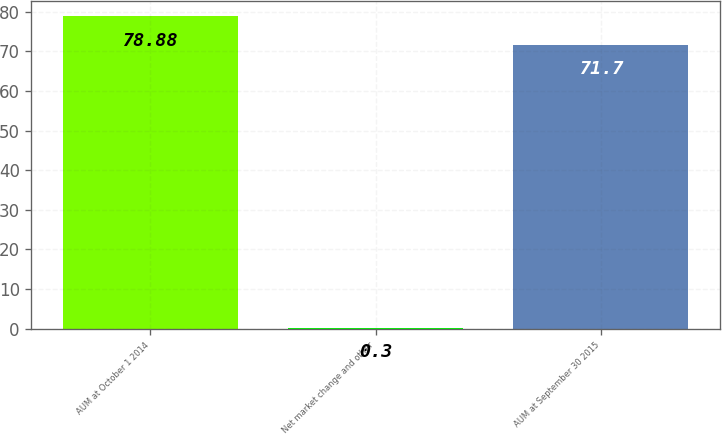Convert chart. <chart><loc_0><loc_0><loc_500><loc_500><bar_chart><fcel>AUM at October 1 2014<fcel>Net market change and other<fcel>AUM at September 30 2015<nl><fcel>78.88<fcel>0.3<fcel>71.7<nl></chart> 